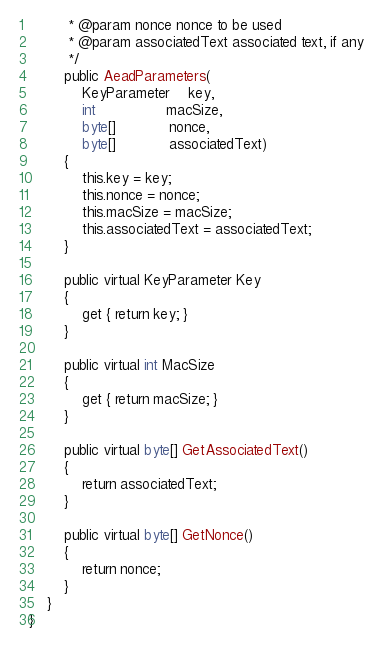<code> <loc_0><loc_0><loc_500><loc_500><_C#_>		 * @param nonce nonce to be used
		 * @param associatedText associated text, if any
		 */
		public AeadParameters(
			KeyParameter	key,
			int				macSize,
			byte[]			nonce,
			byte[]			associatedText)
		{
			this.key = key;
			this.nonce = nonce;
			this.macSize = macSize;
			this.associatedText = associatedText;
		}

		public virtual KeyParameter Key
		{
			get { return key; }
		}

		public virtual int MacSize
		{
			get { return macSize; }
		}

		public virtual byte[] GetAssociatedText()
		{
			return associatedText;
		}

		public virtual byte[] GetNonce()
		{
			return nonce;
		}
	}
}
</code> 